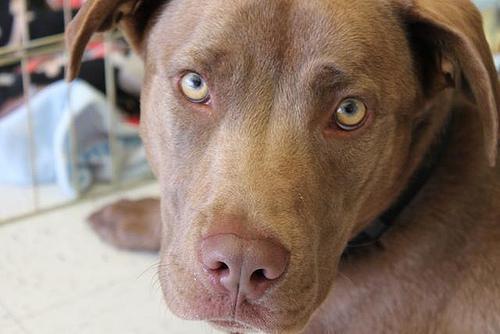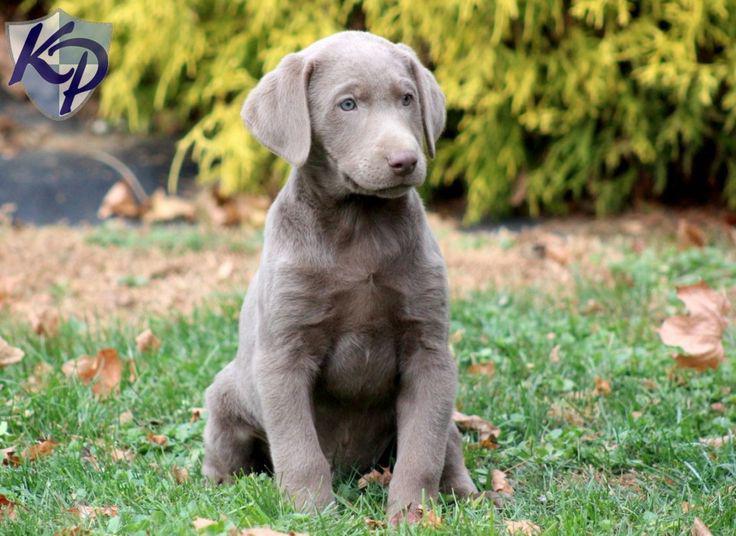The first image is the image on the left, the second image is the image on the right. For the images displayed, is the sentence "Each image contains exactly one dog, all dogs have grey fur, and one dog has its tongue hanging out." factually correct? Answer yes or no. No. The first image is the image on the left, the second image is the image on the right. Analyze the images presented: Is the assertion "The right image contains one dog with its tongue hanging out." valid? Answer yes or no. No. 